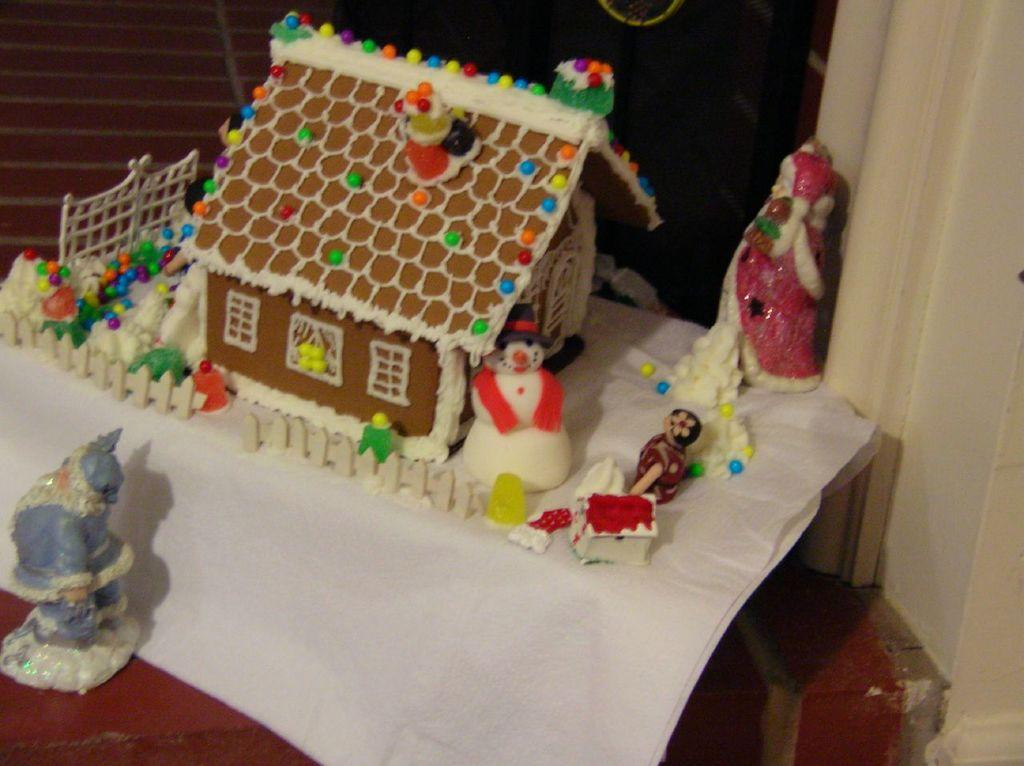What is the color of the main object in the image? The main object in the image is white. What can be found on the white object? There are different types of toys on the white object. Can you describe another object in the image? There is a yellow object in the image. What type of base is supporting the white object in the image? There is no base mentioned or visible in the image. How does the yellow object affect the acoustics in the room? The image does not provide any information about the acoustics in the room or the effect of the yellow object on them. 